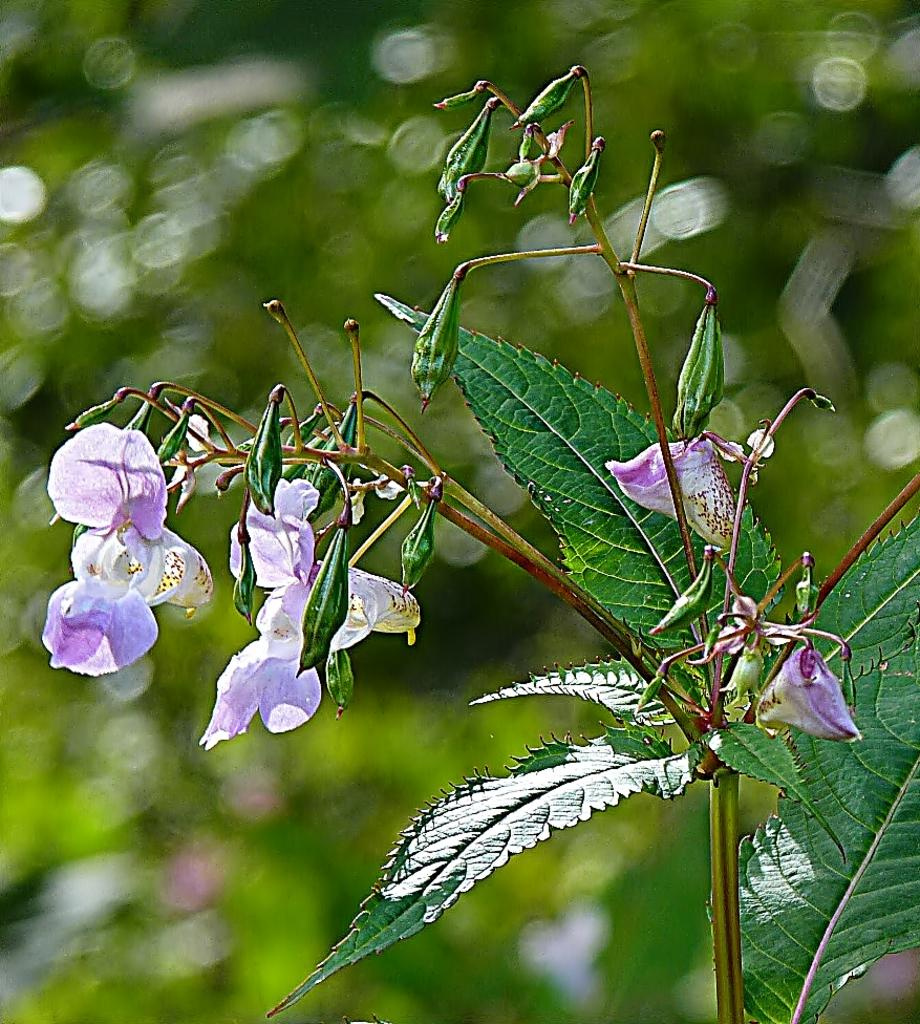What type of plant is visible in the image? There is a plant in the image, with flowers, buds, and green leaves. Can you describe the flowers in the image? Yes, there are flowers in the image. What is the color of the leaves on the plant? The leaves on the plant are green. How would you describe the background of the image? The background of the image is blurred and green and green. Can you see a tray of corn in the image? No, there is no tray of corn present in the image. 